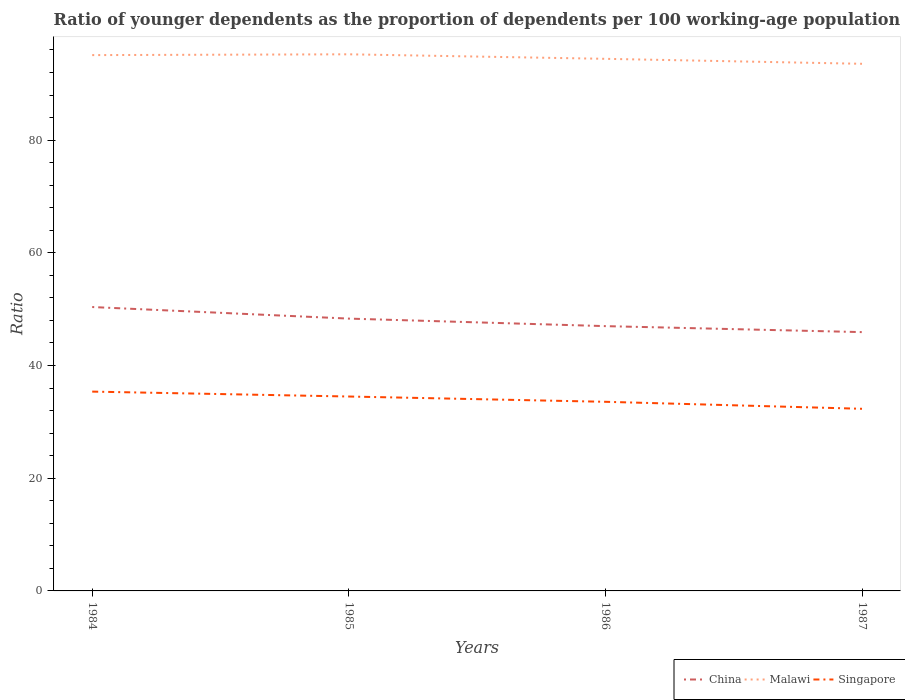How many different coloured lines are there?
Your response must be concise. 3. Does the line corresponding to Malawi intersect with the line corresponding to China?
Offer a terse response. No. Is the number of lines equal to the number of legend labels?
Your answer should be compact. Yes. Across all years, what is the maximum age dependency ratio(young) in China?
Offer a very short reply. 45.93. In which year was the age dependency ratio(young) in China maximum?
Keep it short and to the point. 1987. What is the total age dependency ratio(young) in Malawi in the graph?
Keep it short and to the point. -0.14. What is the difference between the highest and the second highest age dependency ratio(young) in China?
Keep it short and to the point. 4.45. What is the difference between the highest and the lowest age dependency ratio(young) in Singapore?
Provide a succinct answer. 2. Is the age dependency ratio(young) in China strictly greater than the age dependency ratio(young) in Malawi over the years?
Your response must be concise. Yes. Are the values on the major ticks of Y-axis written in scientific E-notation?
Offer a very short reply. No. Does the graph contain any zero values?
Offer a terse response. No. Does the graph contain grids?
Offer a very short reply. No. What is the title of the graph?
Provide a short and direct response. Ratio of younger dependents as the proportion of dependents per 100 working-age population. Does "Lebanon" appear as one of the legend labels in the graph?
Keep it short and to the point. No. What is the label or title of the X-axis?
Offer a terse response. Years. What is the label or title of the Y-axis?
Provide a succinct answer. Ratio. What is the Ratio of China in 1984?
Your response must be concise. 50.38. What is the Ratio in Malawi in 1984?
Offer a terse response. 95.08. What is the Ratio of Singapore in 1984?
Your answer should be compact. 35.37. What is the Ratio of China in 1985?
Offer a very short reply. 48.32. What is the Ratio in Malawi in 1985?
Ensure brevity in your answer.  95.22. What is the Ratio of Singapore in 1985?
Make the answer very short. 34.5. What is the Ratio in China in 1986?
Provide a succinct answer. 46.99. What is the Ratio in Malawi in 1986?
Offer a terse response. 94.42. What is the Ratio of Singapore in 1986?
Give a very brief answer. 33.56. What is the Ratio of China in 1987?
Offer a very short reply. 45.93. What is the Ratio of Malawi in 1987?
Your answer should be compact. 93.54. What is the Ratio in Singapore in 1987?
Keep it short and to the point. 32.32. Across all years, what is the maximum Ratio of China?
Give a very brief answer. 50.38. Across all years, what is the maximum Ratio in Malawi?
Offer a very short reply. 95.22. Across all years, what is the maximum Ratio in Singapore?
Offer a very short reply. 35.37. Across all years, what is the minimum Ratio in China?
Offer a very short reply. 45.93. Across all years, what is the minimum Ratio of Malawi?
Keep it short and to the point. 93.54. Across all years, what is the minimum Ratio in Singapore?
Your answer should be compact. 32.32. What is the total Ratio in China in the graph?
Your answer should be compact. 191.61. What is the total Ratio in Malawi in the graph?
Offer a very short reply. 378.26. What is the total Ratio of Singapore in the graph?
Offer a very short reply. 135.75. What is the difference between the Ratio in China in 1984 and that in 1985?
Offer a terse response. 2.05. What is the difference between the Ratio of Malawi in 1984 and that in 1985?
Give a very brief answer. -0.14. What is the difference between the Ratio of Singapore in 1984 and that in 1985?
Provide a succinct answer. 0.87. What is the difference between the Ratio of China in 1984 and that in 1986?
Offer a terse response. 3.39. What is the difference between the Ratio of Malawi in 1984 and that in 1986?
Offer a terse response. 0.66. What is the difference between the Ratio of Singapore in 1984 and that in 1986?
Offer a very short reply. 1.81. What is the difference between the Ratio in China in 1984 and that in 1987?
Offer a terse response. 4.45. What is the difference between the Ratio in Malawi in 1984 and that in 1987?
Make the answer very short. 1.54. What is the difference between the Ratio of Singapore in 1984 and that in 1987?
Your answer should be compact. 3.05. What is the difference between the Ratio of China in 1985 and that in 1986?
Offer a terse response. 1.33. What is the difference between the Ratio of Malawi in 1985 and that in 1986?
Your answer should be compact. 0.8. What is the difference between the Ratio in Singapore in 1985 and that in 1986?
Provide a succinct answer. 0.94. What is the difference between the Ratio in China in 1985 and that in 1987?
Provide a succinct answer. 2.4. What is the difference between the Ratio in Malawi in 1985 and that in 1987?
Give a very brief answer. 1.68. What is the difference between the Ratio in Singapore in 1985 and that in 1987?
Your answer should be compact. 2.18. What is the difference between the Ratio of China in 1986 and that in 1987?
Give a very brief answer. 1.06. What is the difference between the Ratio in Malawi in 1986 and that in 1987?
Offer a terse response. 0.88. What is the difference between the Ratio of Singapore in 1986 and that in 1987?
Provide a short and direct response. 1.24. What is the difference between the Ratio of China in 1984 and the Ratio of Malawi in 1985?
Your response must be concise. -44.85. What is the difference between the Ratio in China in 1984 and the Ratio in Singapore in 1985?
Offer a terse response. 15.88. What is the difference between the Ratio in Malawi in 1984 and the Ratio in Singapore in 1985?
Your answer should be compact. 60.58. What is the difference between the Ratio of China in 1984 and the Ratio of Malawi in 1986?
Give a very brief answer. -44.04. What is the difference between the Ratio of China in 1984 and the Ratio of Singapore in 1986?
Ensure brevity in your answer.  16.82. What is the difference between the Ratio of Malawi in 1984 and the Ratio of Singapore in 1986?
Provide a succinct answer. 61.52. What is the difference between the Ratio of China in 1984 and the Ratio of Malawi in 1987?
Offer a terse response. -43.16. What is the difference between the Ratio of China in 1984 and the Ratio of Singapore in 1987?
Your answer should be very brief. 18.06. What is the difference between the Ratio in Malawi in 1984 and the Ratio in Singapore in 1987?
Your answer should be very brief. 62.76. What is the difference between the Ratio in China in 1985 and the Ratio in Malawi in 1986?
Keep it short and to the point. -46.1. What is the difference between the Ratio of China in 1985 and the Ratio of Singapore in 1986?
Provide a short and direct response. 14.76. What is the difference between the Ratio in Malawi in 1985 and the Ratio in Singapore in 1986?
Your answer should be very brief. 61.66. What is the difference between the Ratio in China in 1985 and the Ratio in Malawi in 1987?
Your answer should be very brief. -45.22. What is the difference between the Ratio of China in 1985 and the Ratio of Singapore in 1987?
Make the answer very short. 16. What is the difference between the Ratio in Malawi in 1985 and the Ratio in Singapore in 1987?
Your answer should be very brief. 62.9. What is the difference between the Ratio of China in 1986 and the Ratio of Malawi in 1987?
Offer a terse response. -46.55. What is the difference between the Ratio of China in 1986 and the Ratio of Singapore in 1987?
Your answer should be compact. 14.67. What is the difference between the Ratio in Malawi in 1986 and the Ratio in Singapore in 1987?
Give a very brief answer. 62.1. What is the average Ratio in China per year?
Provide a short and direct response. 47.9. What is the average Ratio of Malawi per year?
Offer a very short reply. 94.57. What is the average Ratio of Singapore per year?
Offer a very short reply. 33.94. In the year 1984, what is the difference between the Ratio in China and Ratio in Malawi?
Your response must be concise. -44.7. In the year 1984, what is the difference between the Ratio of China and Ratio of Singapore?
Keep it short and to the point. 15.01. In the year 1984, what is the difference between the Ratio in Malawi and Ratio in Singapore?
Give a very brief answer. 59.71. In the year 1985, what is the difference between the Ratio in China and Ratio in Malawi?
Make the answer very short. -46.9. In the year 1985, what is the difference between the Ratio in China and Ratio in Singapore?
Your response must be concise. 13.82. In the year 1985, what is the difference between the Ratio of Malawi and Ratio of Singapore?
Provide a succinct answer. 60.73. In the year 1986, what is the difference between the Ratio of China and Ratio of Malawi?
Offer a very short reply. -47.43. In the year 1986, what is the difference between the Ratio of China and Ratio of Singapore?
Offer a very short reply. 13.43. In the year 1986, what is the difference between the Ratio of Malawi and Ratio of Singapore?
Keep it short and to the point. 60.86. In the year 1987, what is the difference between the Ratio in China and Ratio in Malawi?
Your response must be concise. -47.61. In the year 1987, what is the difference between the Ratio of China and Ratio of Singapore?
Provide a succinct answer. 13.61. In the year 1987, what is the difference between the Ratio of Malawi and Ratio of Singapore?
Keep it short and to the point. 61.22. What is the ratio of the Ratio of China in 1984 to that in 1985?
Your answer should be compact. 1.04. What is the ratio of the Ratio of Malawi in 1984 to that in 1985?
Ensure brevity in your answer.  1. What is the ratio of the Ratio of Singapore in 1984 to that in 1985?
Make the answer very short. 1.03. What is the ratio of the Ratio in China in 1984 to that in 1986?
Provide a short and direct response. 1.07. What is the ratio of the Ratio in Singapore in 1984 to that in 1986?
Provide a succinct answer. 1.05. What is the ratio of the Ratio of China in 1984 to that in 1987?
Provide a succinct answer. 1.1. What is the ratio of the Ratio of Malawi in 1984 to that in 1987?
Your answer should be compact. 1.02. What is the ratio of the Ratio of Singapore in 1984 to that in 1987?
Make the answer very short. 1.09. What is the ratio of the Ratio in China in 1985 to that in 1986?
Your response must be concise. 1.03. What is the ratio of the Ratio of Malawi in 1985 to that in 1986?
Provide a succinct answer. 1.01. What is the ratio of the Ratio of Singapore in 1985 to that in 1986?
Provide a succinct answer. 1.03. What is the ratio of the Ratio of China in 1985 to that in 1987?
Your answer should be very brief. 1.05. What is the ratio of the Ratio of Malawi in 1985 to that in 1987?
Provide a succinct answer. 1.02. What is the ratio of the Ratio in Singapore in 1985 to that in 1987?
Ensure brevity in your answer.  1.07. What is the ratio of the Ratio of China in 1986 to that in 1987?
Give a very brief answer. 1.02. What is the ratio of the Ratio in Malawi in 1986 to that in 1987?
Your response must be concise. 1.01. What is the ratio of the Ratio of Singapore in 1986 to that in 1987?
Your answer should be very brief. 1.04. What is the difference between the highest and the second highest Ratio in China?
Provide a short and direct response. 2.05. What is the difference between the highest and the second highest Ratio of Malawi?
Give a very brief answer. 0.14. What is the difference between the highest and the second highest Ratio of Singapore?
Offer a terse response. 0.87. What is the difference between the highest and the lowest Ratio in China?
Your answer should be very brief. 4.45. What is the difference between the highest and the lowest Ratio in Malawi?
Keep it short and to the point. 1.68. What is the difference between the highest and the lowest Ratio of Singapore?
Make the answer very short. 3.05. 